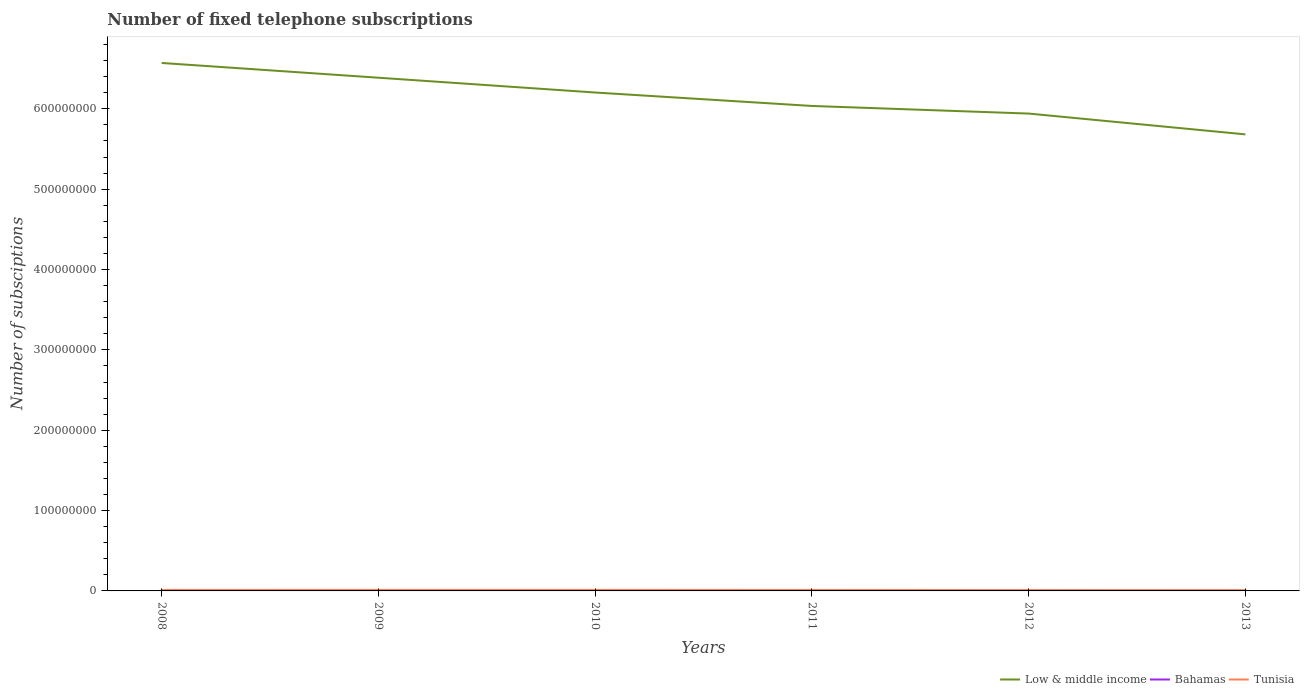How many different coloured lines are there?
Provide a short and direct response. 3. Does the line corresponding to Low & middle income intersect with the line corresponding to Bahamas?
Give a very brief answer. No. Is the number of lines equal to the number of legend labels?
Keep it short and to the point. Yes. Across all years, what is the maximum number of fixed telephone subscriptions in Tunisia?
Your answer should be compact. 1.02e+06. In which year was the number of fixed telephone subscriptions in Tunisia maximum?
Give a very brief answer. 2013. What is the total number of fixed telephone subscriptions in Low & middle income in the graph?
Your answer should be very brief. 5.21e+07. What is the difference between the highest and the second highest number of fixed telephone subscriptions in Low & middle income?
Your answer should be very brief. 8.89e+07. What is the difference between the highest and the lowest number of fixed telephone subscriptions in Low & middle income?
Make the answer very short. 3. How many lines are there?
Your answer should be very brief. 3. What is the difference between two consecutive major ticks on the Y-axis?
Offer a terse response. 1.00e+08. Does the graph contain any zero values?
Your response must be concise. No. How many legend labels are there?
Your answer should be compact. 3. What is the title of the graph?
Make the answer very short. Number of fixed telephone subscriptions. What is the label or title of the X-axis?
Keep it short and to the point. Years. What is the label or title of the Y-axis?
Your response must be concise. Number of subsciptions. What is the Number of subsciptions of Low & middle income in 2008?
Provide a short and direct response. 6.57e+08. What is the Number of subsciptions in Bahamas in 2008?
Provide a short and direct response. 1.33e+05. What is the Number of subsciptions in Tunisia in 2008?
Keep it short and to the point. 1.24e+06. What is the Number of subsciptions in Low & middle income in 2009?
Provide a short and direct response. 6.39e+08. What is the Number of subsciptions of Bahamas in 2009?
Provide a succinct answer. 1.29e+05. What is the Number of subsciptions of Tunisia in 2009?
Give a very brief answer. 1.28e+06. What is the Number of subsciptions in Low & middle income in 2010?
Keep it short and to the point. 6.20e+08. What is the Number of subsciptions of Bahamas in 2010?
Give a very brief answer. 1.29e+05. What is the Number of subsciptions in Tunisia in 2010?
Your response must be concise. 1.29e+06. What is the Number of subsciptions of Low & middle income in 2011?
Your answer should be very brief. 6.04e+08. What is the Number of subsciptions in Bahamas in 2011?
Your answer should be very brief. 1.33e+05. What is the Number of subsciptions in Tunisia in 2011?
Your answer should be very brief. 1.22e+06. What is the Number of subsciptions in Low & middle income in 2012?
Ensure brevity in your answer.  5.94e+08. What is the Number of subsciptions of Bahamas in 2012?
Provide a short and direct response. 1.35e+05. What is the Number of subsciptions of Tunisia in 2012?
Offer a very short reply. 1.10e+06. What is the Number of subsciptions in Low & middle income in 2013?
Provide a short and direct response. 5.68e+08. What is the Number of subsciptions in Bahamas in 2013?
Provide a short and direct response. 1.36e+05. What is the Number of subsciptions of Tunisia in 2013?
Offer a terse response. 1.02e+06. Across all years, what is the maximum Number of subsciptions of Low & middle income?
Provide a succinct answer. 6.57e+08. Across all years, what is the maximum Number of subsciptions in Bahamas?
Provide a succinct answer. 1.36e+05. Across all years, what is the maximum Number of subsciptions of Tunisia?
Make the answer very short. 1.29e+06. Across all years, what is the minimum Number of subsciptions of Low & middle income?
Make the answer very short. 5.68e+08. Across all years, what is the minimum Number of subsciptions in Bahamas?
Make the answer very short. 1.29e+05. Across all years, what is the minimum Number of subsciptions in Tunisia?
Give a very brief answer. 1.02e+06. What is the total Number of subsciptions of Low & middle income in the graph?
Provide a short and direct response. 3.68e+09. What is the total Number of subsciptions in Bahamas in the graph?
Ensure brevity in your answer.  7.95e+05. What is the total Number of subsciptions in Tunisia in the graph?
Ensure brevity in your answer.  7.15e+06. What is the difference between the Number of subsciptions in Low & middle income in 2008 and that in 2009?
Provide a short and direct response. 1.83e+07. What is the difference between the Number of subsciptions in Bahamas in 2008 and that in 2009?
Your response must be concise. 3792. What is the difference between the Number of subsciptions of Tunisia in 2008 and that in 2009?
Make the answer very short. -3.95e+04. What is the difference between the Number of subsciptions of Low & middle income in 2008 and that in 2010?
Ensure brevity in your answer.  3.68e+07. What is the difference between the Number of subsciptions in Bahamas in 2008 and that in 2010?
Make the answer very short. 3442. What is the difference between the Number of subsciptions of Tunisia in 2008 and that in 2010?
Offer a very short reply. -5.05e+04. What is the difference between the Number of subsciptions in Low & middle income in 2008 and that in 2011?
Offer a terse response. 5.35e+07. What is the difference between the Number of subsciptions of Bahamas in 2008 and that in 2011?
Your response must be concise. -239. What is the difference between the Number of subsciptions in Tunisia in 2008 and that in 2011?
Provide a short and direct response. 2.13e+04. What is the difference between the Number of subsciptions of Low & middle income in 2008 and that in 2012?
Provide a short and direct response. 6.30e+07. What is the difference between the Number of subsciptions in Bahamas in 2008 and that in 2012?
Provide a short and direct response. -2244. What is the difference between the Number of subsciptions of Tunisia in 2008 and that in 2012?
Offer a very short reply. 1.40e+05. What is the difference between the Number of subsciptions in Low & middle income in 2008 and that in 2013?
Keep it short and to the point. 8.89e+07. What is the difference between the Number of subsciptions of Bahamas in 2008 and that in 2013?
Your response must be concise. -3244. What is the difference between the Number of subsciptions of Tunisia in 2008 and that in 2013?
Your answer should be compact. 2.17e+05. What is the difference between the Number of subsciptions in Low & middle income in 2009 and that in 2010?
Give a very brief answer. 1.84e+07. What is the difference between the Number of subsciptions of Bahamas in 2009 and that in 2010?
Make the answer very short. -350. What is the difference between the Number of subsciptions in Tunisia in 2009 and that in 2010?
Your answer should be compact. -1.10e+04. What is the difference between the Number of subsciptions of Low & middle income in 2009 and that in 2011?
Keep it short and to the point. 3.51e+07. What is the difference between the Number of subsciptions of Bahamas in 2009 and that in 2011?
Make the answer very short. -4031. What is the difference between the Number of subsciptions in Tunisia in 2009 and that in 2011?
Ensure brevity in your answer.  6.08e+04. What is the difference between the Number of subsciptions of Low & middle income in 2009 and that in 2012?
Make the answer very short. 4.46e+07. What is the difference between the Number of subsciptions of Bahamas in 2009 and that in 2012?
Offer a terse response. -6036. What is the difference between the Number of subsciptions in Tunisia in 2009 and that in 2012?
Offer a very short reply. 1.80e+05. What is the difference between the Number of subsciptions in Low & middle income in 2009 and that in 2013?
Ensure brevity in your answer.  7.05e+07. What is the difference between the Number of subsciptions of Bahamas in 2009 and that in 2013?
Provide a short and direct response. -7036. What is the difference between the Number of subsciptions of Tunisia in 2009 and that in 2013?
Your response must be concise. 2.57e+05. What is the difference between the Number of subsciptions in Low & middle income in 2010 and that in 2011?
Your response must be concise. 1.67e+07. What is the difference between the Number of subsciptions in Bahamas in 2010 and that in 2011?
Give a very brief answer. -3681. What is the difference between the Number of subsciptions of Tunisia in 2010 and that in 2011?
Provide a succinct answer. 7.18e+04. What is the difference between the Number of subsciptions of Low & middle income in 2010 and that in 2012?
Your answer should be very brief. 2.62e+07. What is the difference between the Number of subsciptions of Bahamas in 2010 and that in 2012?
Offer a terse response. -5686. What is the difference between the Number of subsciptions in Tunisia in 2010 and that in 2012?
Your answer should be very brief. 1.91e+05. What is the difference between the Number of subsciptions in Low & middle income in 2010 and that in 2013?
Provide a succinct answer. 5.21e+07. What is the difference between the Number of subsciptions in Bahamas in 2010 and that in 2013?
Provide a succinct answer. -6686. What is the difference between the Number of subsciptions of Tunisia in 2010 and that in 2013?
Provide a succinct answer. 2.68e+05. What is the difference between the Number of subsciptions of Low & middle income in 2011 and that in 2012?
Ensure brevity in your answer.  9.47e+06. What is the difference between the Number of subsciptions in Bahamas in 2011 and that in 2012?
Offer a very short reply. -2005. What is the difference between the Number of subsciptions in Tunisia in 2011 and that in 2012?
Give a very brief answer. 1.19e+05. What is the difference between the Number of subsciptions in Low & middle income in 2011 and that in 2013?
Keep it short and to the point. 3.54e+07. What is the difference between the Number of subsciptions in Bahamas in 2011 and that in 2013?
Make the answer very short. -3005. What is the difference between the Number of subsciptions in Tunisia in 2011 and that in 2013?
Provide a short and direct response. 1.96e+05. What is the difference between the Number of subsciptions of Low & middle income in 2012 and that in 2013?
Give a very brief answer. 2.59e+07. What is the difference between the Number of subsciptions of Bahamas in 2012 and that in 2013?
Provide a short and direct response. -1000. What is the difference between the Number of subsciptions in Tunisia in 2012 and that in 2013?
Your response must be concise. 7.69e+04. What is the difference between the Number of subsciptions of Low & middle income in 2008 and the Number of subsciptions of Bahamas in 2009?
Ensure brevity in your answer.  6.57e+08. What is the difference between the Number of subsciptions in Low & middle income in 2008 and the Number of subsciptions in Tunisia in 2009?
Your answer should be very brief. 6.56e+08. What is the difference between the Number of subsciptions in Bahamas in 2008 and the Number of subsciptions in Tunisia in 2009?
Keep it short and to the point. -1.15e+06. What is the difference between the Number of subsciptions of Low & middle income in 2008 and the Number of subsciptions of Bahamas in 2010?
Your answer should be compact. 6.57e+08. What is the difference between the Number of subsciptions in Low & middle income in 2008 and the Number of subsciptions in Tunisia in 2010?
Give a very brief answer. 6.56e+08. What is the difference between the Number of subsciptions in Bahamas in 2008 and the Number of subsciptions in Tunisia in 2010?
Offer a very short reply. -1.16e+06. What is the difference between the Number of subsciptions in Low & middle income in 2008 and the Number of subsciptions in Bahamas in 2011?
Offer a terse response. 6.57e+08. What is the difference between the Number of subsciptions of Low & middle income in 2008 and the Number of subsciptions of Tunisia in 2011?
Offer a terse response. 6.56e+08. What is the difference between the Number of subsciptions of Bahamas in 2008 and the Number of subsciptions of Tunisia in 2011?
Offer a very short reply. -1.09e+06. What is the difference between the Number of subsciptions of Low & middle income in 2008 and the Number of subsciptions of Bahamas in 2012?
Give a very brief answer. 6.57e+08. What is the difference between the Number of subsciptions in Low & middle income in 2008 and the Number of subsciptions in Tunisia in 2012?
Your answer should be very brief. 6.56e+08. What is the difference between the Number of subsciptions of Bahamas in 2008 and the Number of subsciptions of Tunisia in 2012?
Offer a very short reply. -9.66e+05. What is the difference between the Number of subsciptions in Low & middle income in 2008 and the Number of subsciptions in Bahamas in 2013?
Keep it short and to the point. 6.57e+08. What is the difference between the Number of subsciptions in Low & middle income in 2008 and the Number of subsciptions in Tunisia in 2013?
Offer a terse response. 6.56e+08. What is the difference between the Number of subsciptions in Bahamas in 2008 and the Number of subsciptions in Tunisia in 2013?
Provide a succinct answer. -8.89e+05. What is the difference between the Number of subsciptions of Low & middle income in 2009 and the Number of subsciptions of Bahamas in 2010?
Offer a very short reply. 6.39e+08. What is the difference between the Number of subsciptions of Low & middle income in 2009 and the Number of subsciptions of Tunisia in 2010?
Provide a short and direct response. 6.37e+08. What is the difference between the Number of subsciptions in Bahamas in 2009 and the Number of subsciptions in Tunisia in 2010?
Your answer should be very brief. -1.16e+06. What is the difference between the Number of subsciptions of Low & middle income in 2009 and the Number of subsciptions of Bahamas in 2011?
Your answer should be very brief. 6.39e+08. What is the difference between the Number of subsciptions in Low & middle income in 2009 and the Number of subsciptions in Tunisia in 2011?
Your response must be concise. 6.38e+08. What is the difference between the Number of subsciptions of Bahamas in 2009 and the Number of subsciptions of Tunisia in 2011?
Make the answer very short. -1.09e+06. What is the difference between the Number of subsciptions in Low & middle income in 2009 and the Number of subsciptions in Bahamas in 2012?
Give a very brief answer. 6.39e+08. What is the difference between the Number of subsciptions in Low & middle income in 2009 and the Number of subsciptions in Tunisia in 2012?
Provide a short and direct response. 6.38e+08. What is the difference between the Number of subsciptions of Bahamas in 2009 and the Number of subsciptions of Tunisia in 2012?
Your answer should be compact. -9.70e+05. What is the difference between the Number of subsciptions of Low & middle income in 2009 and the Number of subsciptions of Bahamas in 2013?
Your response must be concise. 6.39e+08. What is the difference between the Number of subsciptions in Low & middle income in 2009 and the Number of subsciptions in Tunisia in 2013?
Give a very brief answer. 6.38e+08. What is the difference between the Number of subsciptions of Bahamas in 2009 and the Number of subsciptions of Tunisia in 2013?
Provide a short and direct response. -8.93e+05. What is the difference between the Number of subsciptions of Low & middle income in 2010 and the Number of subsciptions of Bahamas in 2011?
Offer a very short reply. 6.20e+08. What is the difference between the Number of subsciptions in Low & middle income in 2010 and the Number of subsciptions in Tunisia in 2011?
Ensure brevity in your answer.  6.19e+08. What is the difference between the Number of subsciptions in Bahamas in 2010 and the Number of subsciptions in Tunisia in 2011?
Give a very brief answer. -1.09e+06. What is the difference between the Number of subsciptions in Low & middle income in 2010 and the Number of subsciptions in Bahamas in 2012?
Keep it short and to the point. 6.20e+08. What is the difference between the Number of subsciptions in Low & middle income in 2010 and the Number of subsciptions in Tunisia in 2012?
Your answer should be compact. 6.19e+08. What is the difference between the Number of subsciptions of Bahamas in 2010 and the Number of subsciptions of Tunisia in 2012?
Offer a terse response. -9.70e+05. What is the difference between the Number of subsciptions of Low & middle income in 2010 and the Number of subsciptions of Bahamas in 2013?
Provide a succinct answer. 6.20e+08. What is the difference between the Number of subsciptions of Low & middle income in 2010 and the Number of subsciptions of Tunisia in 2013?
Your response must be concise. 6.19e+08. What is the difference between the Number of subsciptions of Bahamas in 2010 and the Number of subsciptions of Tunisia in 2013?
Your answer should be very brief. -8.93e+05. What is the difference between the Number of subsciptions of Low & middle income in 2011 and the Number of subsciptions of Bahamas in 2012?
Offer a very short reply. 6.03e+08. What is the difference between the Number of subsciptions of Low & middle income in 2011 and the Number of subsciptions of Tunisia in 2012?
Your response must be concise. 6.02e+08. What is the difference between the Number of subsciptions in Bahamas in 2011 and the Number of subsciptions in Tunisia in 2012?
Give a very brief answer. -9.66e+05. What is the difference between the Number of subsciptions of Low & middle income in 2011 and the Number of subsciptions of Bahamas in 2013?
Your answer should be very brief. 6.03e+08. What is the difference between the Number of subsciptions in Low & middle income in 2011 and the Number of subsciptions in Tunisia in 2013?
Offer a terse response. 6.03e+08. What is the difference between the Number of subsciptions of Bahamas in 2011 and the Number of subsciptions of Tunisia in 2013?
Make the answer very short. -8.89e+05. What is the difference between the Number of subsciptions of Low & middle income in 2012 and the Number of subsciptions of Bahamas in 2013?
Keep it short and to the point. 5.94e+08. What is the difference between the Number of subsciptions of Low & middle income in 2012 and the Number of subsciptions of Tunisia in 2013?
Your answer should be very brief. 5.93e+08. What is the difference between the Number of subsciptions of Bahamas in 2012 and the Number of subsciptions of Tunisia in 2013?
Keep it short and to the point. -8.87e+05. What is the average Number of subsciptions of Low & middle income per year?
Your response must be concise. 6.14e+08. What is the average Number of subsciptions in Bahamas per year?
Make the answer very short. 1.33e+05. What is the average Number of subsciptions in Tunisia per year?
Offer a terse response. 1.19e+06. In the year 2008, what is the difference between the Number of subsciptions in Low & middle income and Number of subsciptions in Bahamas?
Ensure brevity in your answer.  6.57e+08. In the year 2008, what is the difference between the Number of subsciptions of Low & middle income and Number of subsciptions of Tunisia?
Provide a succinct answer. 6.56e+08. In the year 2008, what is the difference between the Number of subsciptions in Bahamas and Number of subsciptions in Tunisia?
Ensure brevity in your answer.  -1.11e+06. In the year 2009, what is the difference between the Number of subsciptions in Low & middle income and Number of subsciptions in Bahamas?
Make the answer very short. 6.39e+08. In the year 2009, what is the difference between the Number of subsciptions of Low & middle income and Number of subsciptions of Tunisia?
Your response must be concise. 6.37e+08. In the year 2009, what is the difference between the Number of subsciptions in Bahamas and Number of subsciptions in Tunisia?
Offer a terse response. -1.15e+06. In the year 2010, what is the difference between the Number of subsciptions in Low & middle income and Number of subsciptions in Bahamas?
Offer a terse response. 6.20e+08. In the year 2010, what is the difference between the Number of subsciptions in Low & middle income and Number of subsciptions in Tunisia?
Your answer should be very brief. 6.19e+08. In the year 2010, what is the difference between the Number of subsciptions of Bahamas and Number of subsciptions of Tunisia?
Your answer should be compact. -1.16e+06. In the year 2011, what is the difference between the Number of subsciptions in Low & middle income and Number of subsciptions in Bahamas?
Your answer should be compact. 6.03e+08. In the year 2011, what is the difference between the Number of subsciptions in Low & middle income and Number of subsciptions in Tunisia?
Keep it short and to the point. 6.02e+08. In the year 2011, what is the difference between the Number of subsciptions in Bahamas and Number of subsciptions in Tunisia?
Give a very brief answer. -1.08e+06. In the year 2012, what is the difference between the Number of subsciptions of Low & middle income and Number of subsciptions of Bahamas?
Your response must be concise. 5.94e+08. In the year 2012, what is the difference between the Number of subsciptions in Low & middle income and Number of subsciptions in Tunisia?
Make the answer very short. 5.93e+08. In the year 2012, what is the difference between the Number of subsciptions in Bahamas and Number of subsciptions in Tunisia?
Give a very brief answer. -9.64e+05. In the year 2013, what is the difference between the Number of subsciptions of Low & middle income and Number of subsciptions of Bahamas?
Make the answer very short. 5.68e+08. In the year 2013, what is the difference between the Number of subsciptions of Low & middle income and Number of subsciptions of Tunisia?
Your response must be concise. 5.67e+08. In the year 2013, what is the difference between the Number of subsciptions of Bahamas and Number of subsciptions of Tunisia?
Provide a succinct answer. -8.86e+05. What is the ratio of the Number of subsciptions of Low & middle income in 2008 to that in 2009?
Provide a succinct answer. 1.03. What is the ratio of the Number of subsciptions of Bahamas in 2008 to that in 2009?
Your response must be concise. 1.03. What is the ratio of the Number of subsciptions in Tunisia in 2008 to that in 2009?
Provide a short and direct response. 0.97. What is the ratio of the Number of subsciptions of Low & middle income in 2008 to that in 2010?
Provide a short and direct response. 1.06. What is the ratio of the Number of subsciptions of Bahamas in 2008 to that in 2010?
Provide a succinct answer. 1.03. What is the ratio of the Number of subsciptions in Tunisia in 2008 to that in 2010?
Offer a terse response. 0.96. What is the ratio of the Number of subsciptions in Low & middle income in 2008 to that in 2011?
Your answer should be very brief. 1.09. What is the ratio of the Number of subsciptions in Bahamas in 2008 to that in 2011?
Offer a very short reply. 1. What is the ratio of the Number of subsciptions of Tunisia in 2008 to that in 2011?
Offer a very short reply. 1.02. What is the ratio of the Number of subsciptions in Low & middle income in 2008 to that in 2012?
Your response must be concise. 1.11. What is the ratio of the Number of subsciptions in Bahamas in 2008 to that in 2012?
Provide a succinct answer. 0.98. What is the ratio of the Number of subsciptions of Tunisia in 2008 to that in 2012?
Offer a terse response. 1.13. What is the ratio of the Number of subsciptions of Low & middle income in 2008 to that in 2013?
Provide a succinct answer. 1.16. What is the ratio of the Number of subsciptions of Bahamas in 2008 to that in 2013?
Offer a terse response. 0.98. What is the ratio of the Number of subsciptions of Tunisia in 2008 to that in 2013?
Keep it short and to the point. 1.21. What is the ratio of the Number of subsciptions in Low & middle income in 2009 to that in 2010?
Your response must be concise. 1.03. What is the ratio of the Number of subsciptions in Bahamas in 2009 to that in 2010?
Keep it short and to the point. 1. What is the ratio of the Number of subsciptions of Low & middle income in 2009 to that in 2011?
Offer a terse response. 1.06. What is the ratio of the Number of subsciptions in Bahamas in 2009 to that in 2011?
Offer a very short reply. 0.97. What is the ratio of the Number of subsciptions in Tunisia in 2009 to that in 2011?
Offer a terse response. 1.05. What is the ratio of the Number of subsciptions in Low & middle income in 2009 to that in 2012?
Give a very brief answer. 1.08. What is the ratio of the Number of subsciptions in Bahamas in 2009 to that in 2012?
Ensure brevity in your answer.  0.96. What is the ratio of the Number of subsciptions of Tunisia in 2009 to that in 2012?
Keep it short and to the point. 1.16. What is the ratio of the Number of subsciptions of Low & middle income in 2009 to that in 2013?
Your answer should be compact. 1.12. What is the ratio of the Number of subsciptions of Bahamas in 2009 to that in 2013?
Your response must be concise. 0.95. What is the ratio of the Number of subsciptions in Tunisia in 2009 to that in 2013?
Make the answer very short. 1.25. What is the ratio of the Number of subsciptions in Low & middle income in 2010 to that in 2011?
Offer a terse response. 1.03. What is the ratio of the Number of subsciptions of Bahamas in 2010 to that in 2011?
Make the answer very short. 0.97. What is the ratio of the Number of subsciptions in Tunisia in 2010 to that in 2011?
Give a very brief answer. 1.06. What is the ratio of the Number of subsciptions in Low & middle income in 2010 to that in 2012?
Ensure brevity in your answer.  1.04. What is the ratio of the Number of subsciptions in Bahamas in 2010 to that in 2012?
Give a very brief answer. 0.96. What is the ratio of the Number of subsciptions of Tunisia in 2010 to that in 2012?
Give a very brief answer. 1.17. What is the ratio of the Number of subsciptions of Low & middle income in 2010 to that in 2013?
Your response must be concise. 1.09. What is the ratio of the Number of subsciptions in Bahamas in 2010 to that in 2013?
Provide a short and direct response. 0.95. What is the ratio of the Number of subsciptions in Tunisia in 2010 to that in 2013?
Your answer should be very brief. 1.26. What is the ratio of the Number of subsciptions of Low & middle income in 2011 to that in 2012?
Keep it short and to the point. 1.02. What is the ratio of the Number of subsciptions in Bahamas in 2011 to that in 2012?
Offer a terse response. 0.99. What is the ratio of the Number of subsciptions in Tunisia in 2011 to that in 2012?
Provide a short and direct response. 1.11. What is the ratio of the Number of subsciptions in Low & middle income in 2011 to that in 2013?
Offer a very short reply. 1.06. What is the ratio of the Number of subsciptions in Bahamas in 2011 to that in 2013?
Give a very brief answer. 0.98. What is the ratio of the Number of subsciptions of Tunisia in 2011 to that in 2013?
Your response must be concise. 1.19. What is the ratio of the Number of subsciptions of Low & middle income in 2012 to that in 2013?
Make the answer very short. 1.05. What is the ratio of the Number of subsciptions in Tunisia in 2012 to that in 2013?
Your answer should be very brief. 1.08. What is the difference between the highest and the second highest Number of subsciptions of Low & middle income?
Offer a very short reply. 1.83e+07. What is the difference between the highest and the second highest Number of subsciptions of Bahamas?
Offer a very short reply. 1000. What is the difference between the highest and the second highest Number of subsciptions of Tunisia?
Offer a very short reply. 1.10e+04. What is the difference between the highest and the lowest Number of subsciptions in Low & middle income?
Make the answer very short. 8.89e+07. What is the difference between the highest and the lowest Number of subsciptions in Bahamas?
Provide a short and direct response. 7036. What is the difference between the highest and the lowest Number of subsciptions of Tunisia?
Give a very brief answer. 2.68e+05. 